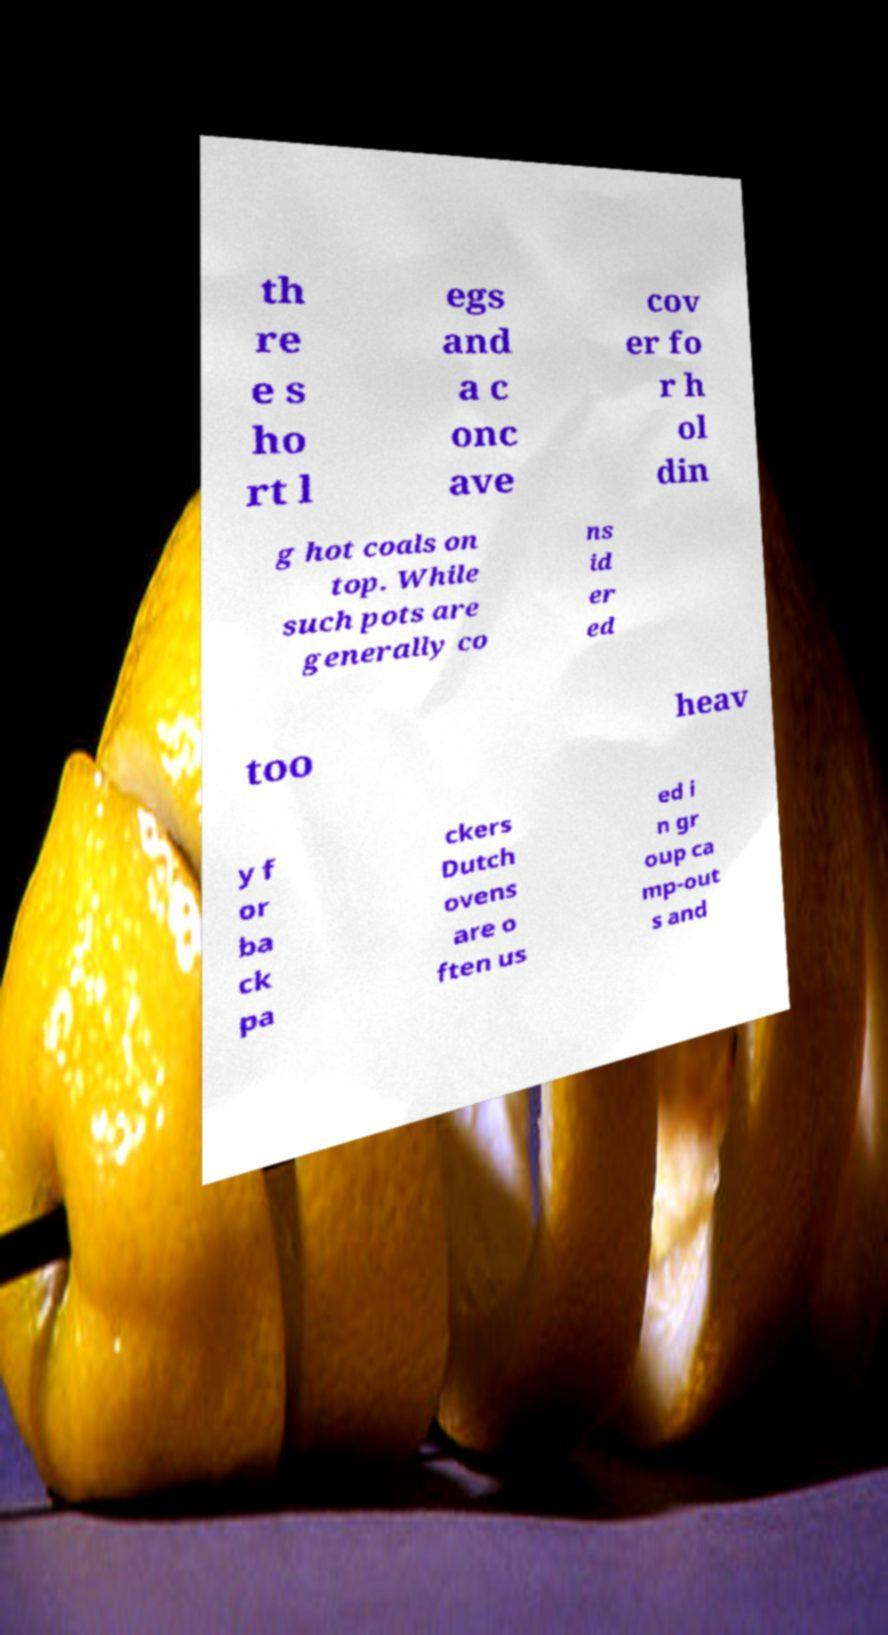Could you assist in decoding the text presented in this image and type it out clearly? th re e s ho rt l egs and a c onc ave cov er fo r h ol din g hot coals on top. While such pots are generally co ns id er ed too heav y f or ba ck pa ckers Dutch ovens are o ften us ed i n gr oup ca mp-out s and 